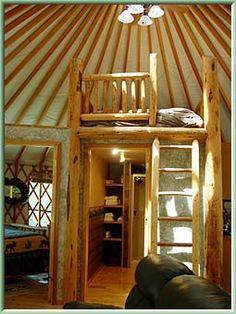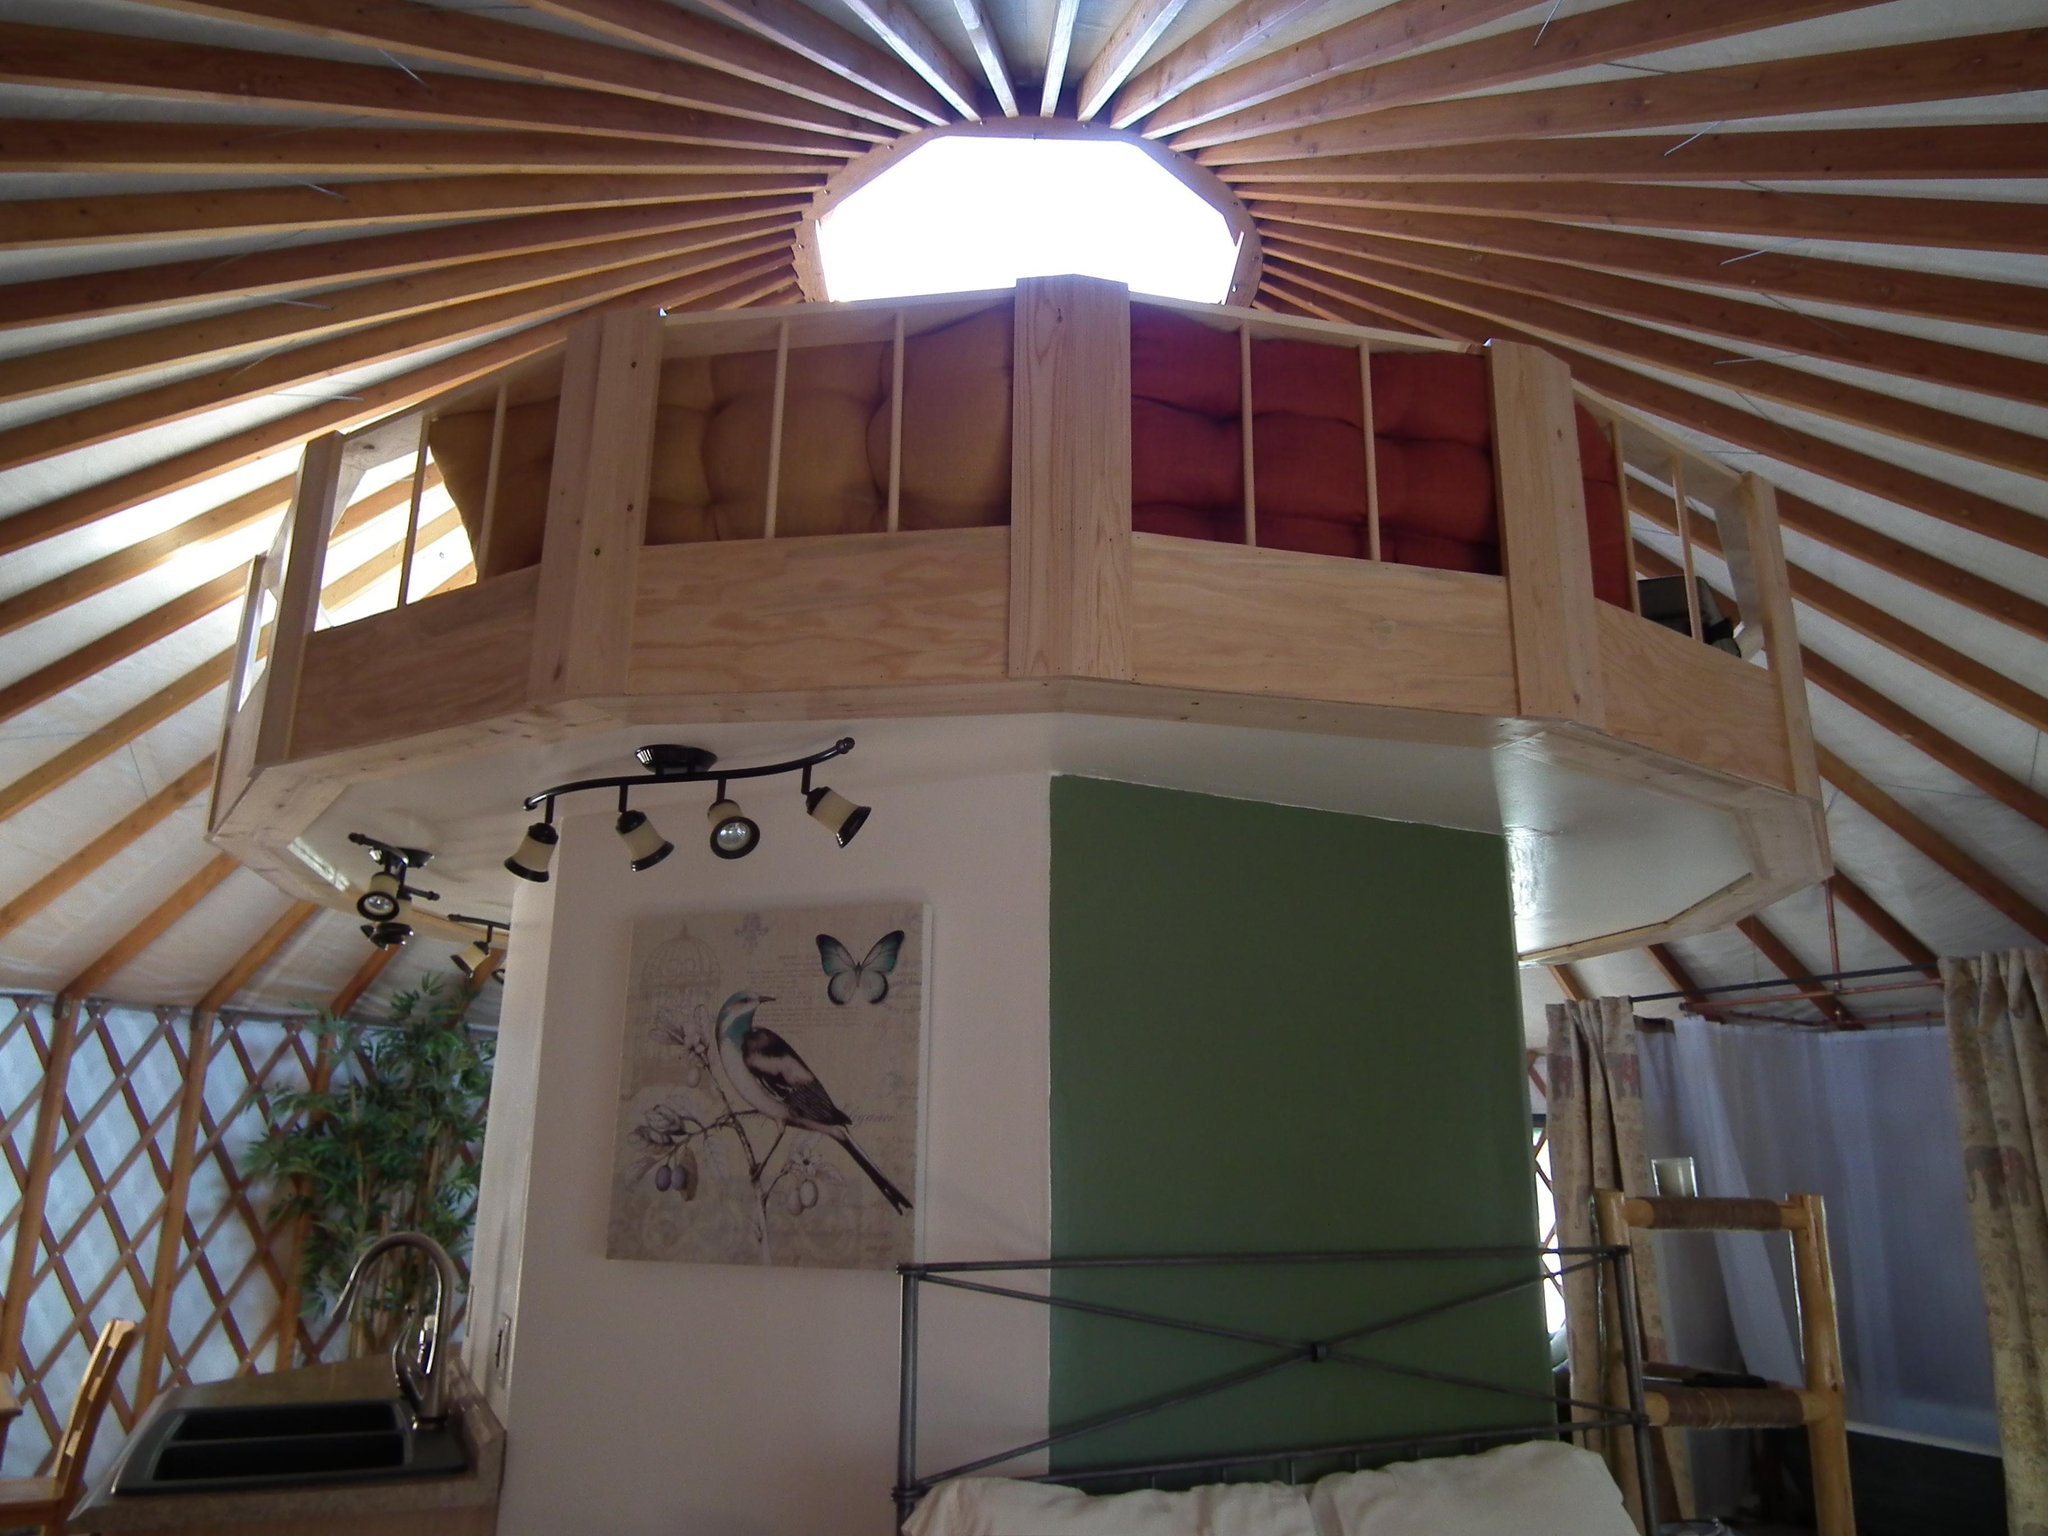The first image is the image on the left, the second image is the image on the right. Evaluate the accuracy of this statement regarding the images: "A painting hangs on the wall in the image on the right.". Is it true? Answer yes or no. Yes. The first image is the image on the left, the second image is the image on the right. Examine the images to the left and right. Is the description "Left image shows a camera-facing ladder in front of a loft area with a railing of vertical posts." accurate? Answer yes or no. Yes. 